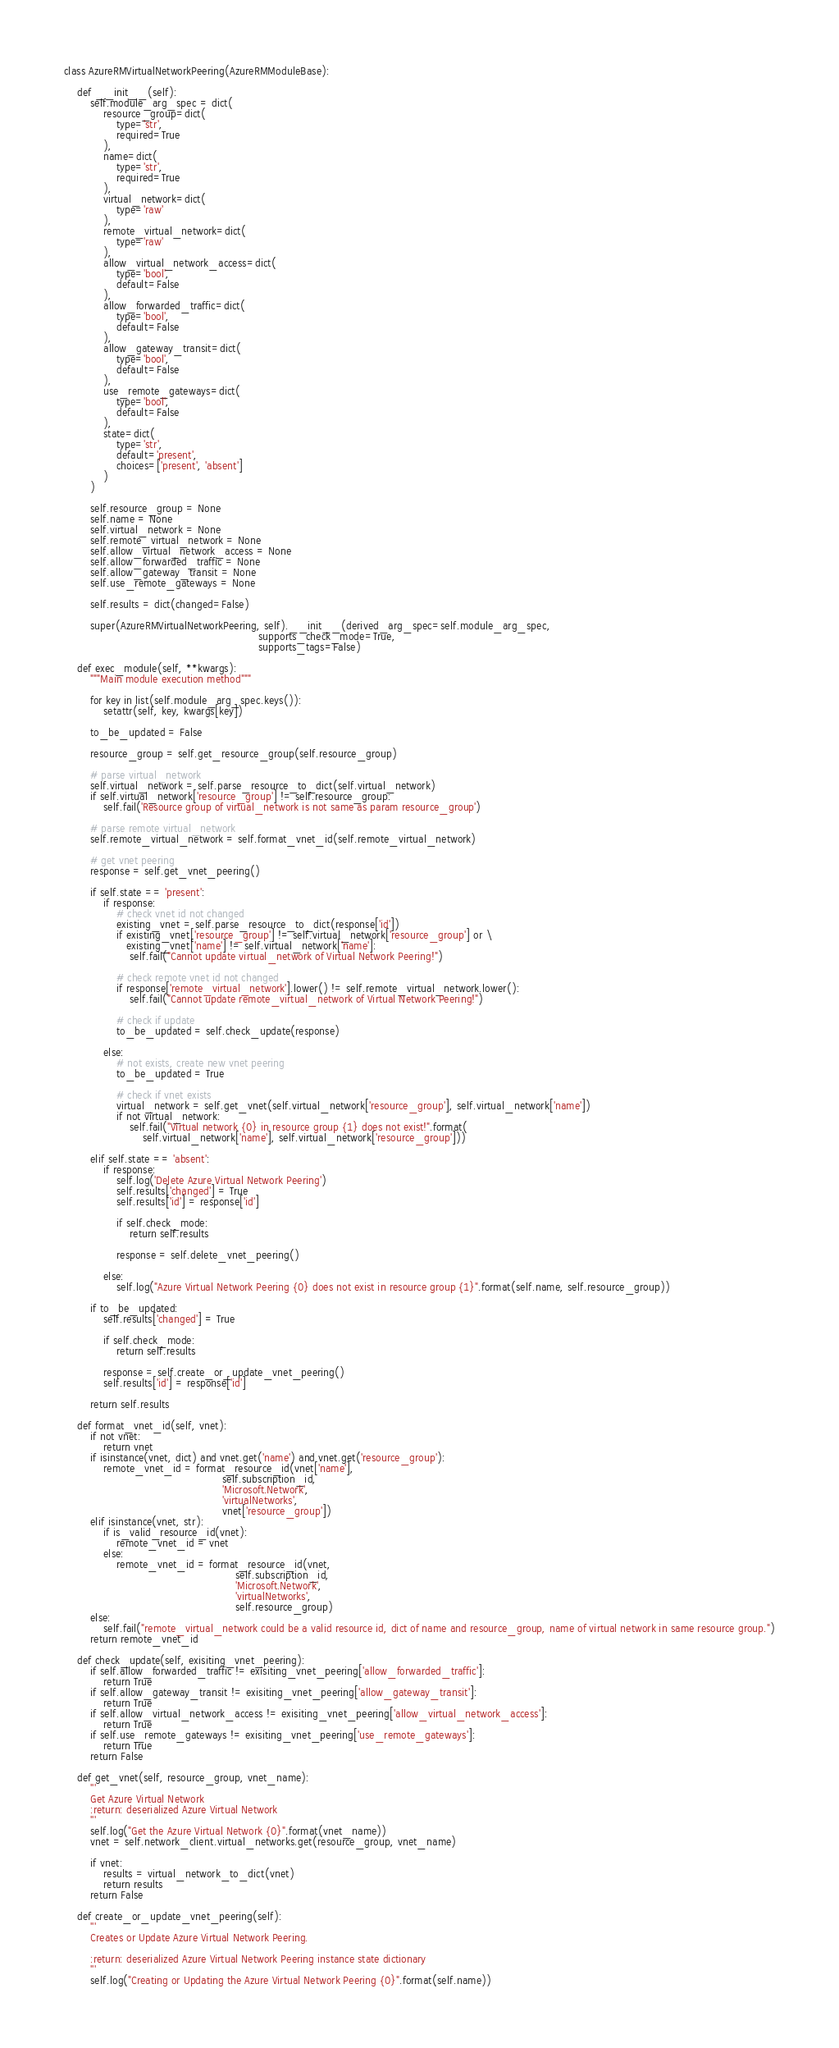<code> <loc_0><loc_0><loc_500><loc_500><_Python_>class AzureRMVirtualNetworkPeering(AzureRMModuleBase):

    def __init__(self):
        self.module_arg_spec = dict(
            resource_group=dict(
                type='str',
                required=True
            ),
            name=dict(
                type='str',
                required=True
            ),
            virtual_network=dict(
                type='raw'
            ),
            remote_virtual_network=dict(
                type='raw'
            ),
            allow_virtual_network_access=dict(
                type='bool',
                default=False
            ),
            allow_forwarded_traffic=dict(
                type='bool',
                default=False
            ),
            allow_gateway_transit=dict(
                type='bool',
                default=False
            ),
            use_remote_gateways=dict(
                type='bool',
                default=False
            ),
            state=dict(
                type='str',
                default='present',
                choices=['present', 'absent']
            )
        )

        self.resource_group = None
        self.name = None
        self.virtual_network = None
        self.remote_virtual_network = None
        self.allow_virtual_network_access = None
        self.allow_forwarded_traffic = None
        self.allow_gateway_transit = None
        self.use_remote_gateways = None

        self.results = dict(changed=False)

        super(AzureRMVirtualNetworkPeering, self).__init__(derived_arg_spec=self.module_arg_spec,
                                                           supports_check_mode=True,
                                                           supports_tags=False)

    def exec_module(self, **kwargs):
        """Main module execution method"""

        for key in list(self.module_arg_spec.keys()):
            setattr(self, key, kwargs[key])

        to_be_updated = False

        resource_group = self.get_resource_group(self.resource_group)

        # parse virtual_network
        self.virtual_network = self.parse_resource_to_dict(self.virtual_network)
        if self.virtual_network['resource_group'] != self.resource_group:
            self.fail('Resource group of virtual_network is not same as param resource_group')

        # parse remote virtual_network
        self.remote_virtual_network = self.format_vnet_id(self.remote_virtual_network)

        # get vnet peering
        response = self.get_vnet_peering()

        if self.state == 'present':
            if response:
                # check vnet id not changed
                existing_vnet = self.parse_resource_to_dict(response['id'])
                if existing_vnet['resource_group'] != self.virtual_network['resource_group'] or \
                   existing_vnet['name'] != self.virtual_network['name']:
                    self.fail("Cannot update virtual_network of Virtual Network Peering!")

                # check remote vnet id not changed
                if response['remote_virtual_network'].lower() != self.remote_virtual_network.lower():
                    self.fail("Cannot update remote_virtual_network of Virtual Network Peering!")

                # check if update
                to_be_updated = self.check_update(response)

            else:
                # not exists, create new vnet peering
                to_be_updated = True

                # check if vnet exists
                virtual_network = self.get_vnet(self.virtual_network['resource_group'], self.virtual_network['name'])
                if not virtual_network:
                    self.fail("Virtual network {0} in resource group {1} does not exist!".format(
                        self.virtual_network['name'], self.virtual_network['resource_group']))

        elif self.state == 'absent':
            if response:
                self.log('Delete Azure Virtual Network Peering')
                self.results['changed'] = True
                self.results['id'] = response['id']

                if self.check_mode:
                    return self.results

                response = self.delete_vnet_peering()

            else:
                self.log("Azure Virtual Network Peering {0} does not exist in resource group {1}".format(self.name, self.resource_group))

        if to_be_updated:
            self.results['changed'] = True

            if self.check_mode:
                return self.results

            response = self.create_or_update_vnet_peering()
            self.results['id'] = response['id']

        return self.results

    def format_vnet_id(self, vnet):
        if not vnet:
            return vnet
        if isinstance(vnet, dict) and vnet.get('name') and vnet.get('resource_group'):
            remote_vnet_id = format_resource_id(vnet['name'],
                                                self.subscription_id,
                                                'Microsoft.Network',
                                                'virtualNetworks',
                                                vnet['resource_group'])
        elif isinstance(vnet, str):
            if is_valid_resource_id(vnet):
                remote_vnet_id = vnet
            else:
                remote_vnet_id = format_resource_id(vnet,
                                                    self.subscription_id,
                                                    'Microsoft.Network',
                                                    'virtualNetworks',
                                                    self.resource_group)
        else:
            self.fail("remote_virtual_network could be a valid resource id, dict of name and resource_group, name of virtual network in same resource group.")
        return remote_vnet_id

    def check_update(self, exisiting_vnet_peering):
        if self.allow_forwarded_traffic != exisiting_vnet_peering['allow_forwarded_traffic']:
            return True
        if self.allow_gateway_transit != exisiting_vnet_peering['allow_gateway_transit']:
            return True
        if self.allow_virtual_network_access != exisiting_vnet_peering['allow_virtual_network_access']:
            return True
        if self.use_remote_gateways != exisiting_vnet_peering['use_remote_gateways']:
            return True
        return False

    def get_vnet(self, resource_group, vnet_name):
        '''
        Get Azure Virtual Network
        :return: deserialized Azure Virtual Network
        '''
        self.log("Get the Azure Virtual Network {0}".format(vnet_name))
        vnet = self.network_client.virtual_networks.get(resource_group, vnet_name)

        if vnet:
            results = virtual_network_to_dict(vnet)
            return results
        return False

    def create_or_update_vnet_peering(self):
        '''
        Creates or Update Azure Virtual Network Peering.

        :return: deserialized Azure Virtual Network Peering instance state dictionary
        '''
        self.log("Creating or Updating the Azure Virtual Network Peering {0}".format(self.name))
</code> 